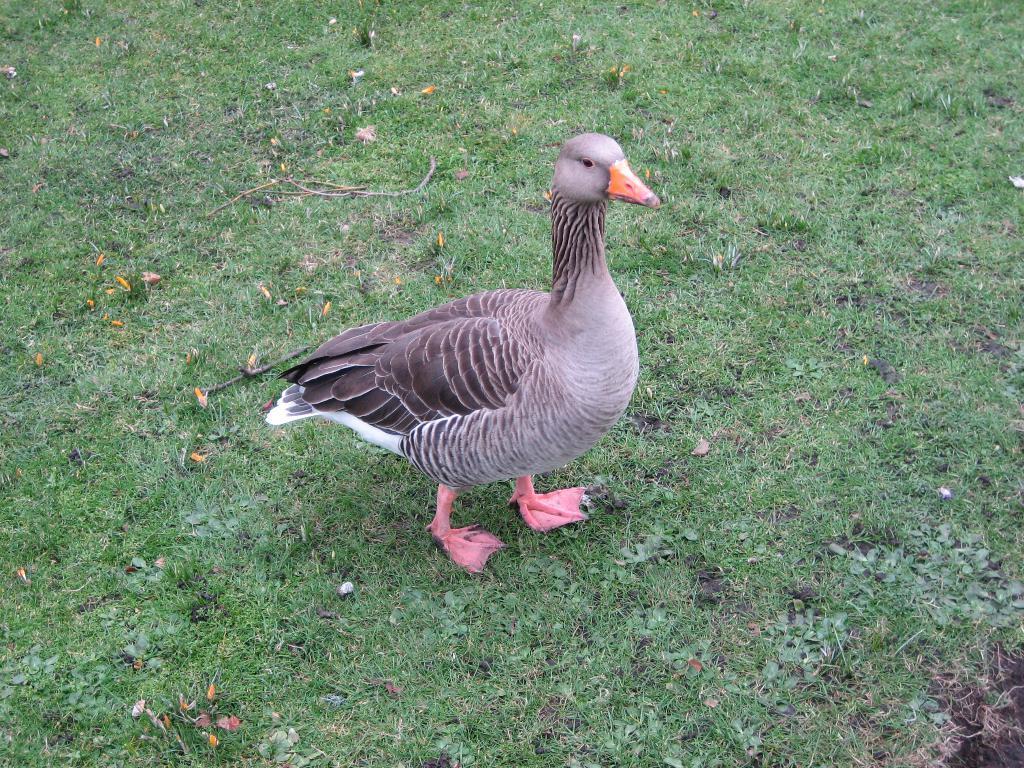Can you describe this image briefly? In this image we can see a bird on the ground and we can see the grass on the ground. 